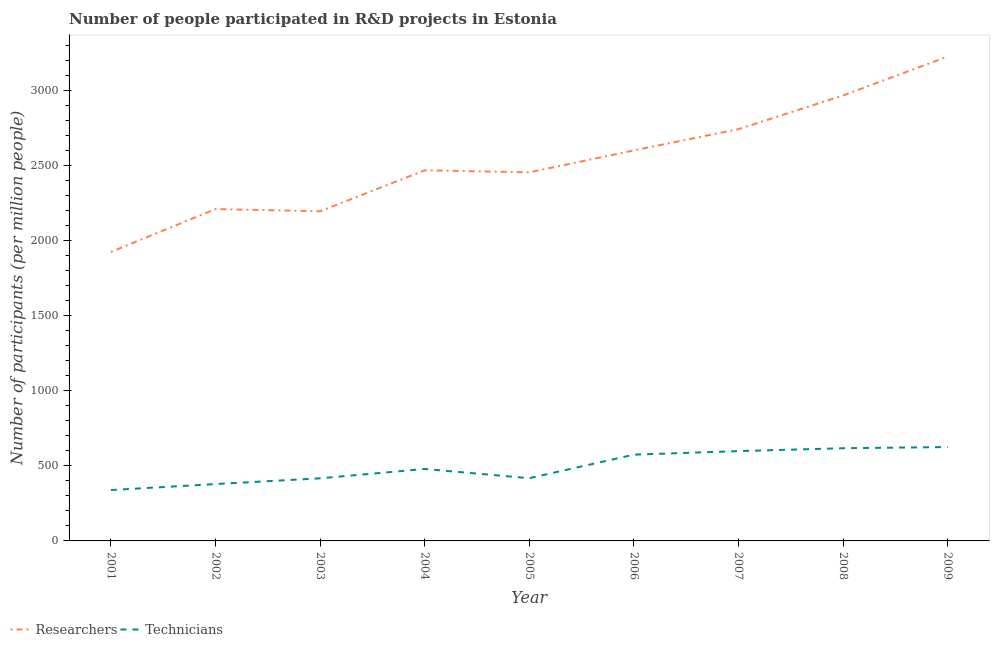Is the number of lines equal to the number of legend labels?
Offer a very short reply. Yes. What is the number of researchers in 2008?
Provide a short and direct response. 2969.53. Across all years, what is the maximum number of technicians?
Your answer should be compact. 625.74. Across all years, what is the minimum number of researchers?
Make the answer very short. 1926.35. In which year was the number of technicians maximum?
Keep it short and to the point. 2009. In which year was the number of technicians minimum?
Your response must be concise. 2001. What is the total number of technicians in the graph?
Give a very brief answer. 4450.96. What is the difference between the number of researchers in 2001 and that in 2009?
Ensure brevity in your answer.  -1302.66. What is the difference between the number of researchers in 2007 and the number of technicians in 2009?
Make the answer very short. 2119.32. What is the average number of researchers per year?
Offer a very short reply. 2534.57. In the year 2008, what is the difference between the number of researchers and number of technicians?
Offer a terse response. 2351.6. In how many years, is the number of researchers greater than 500?
Provide a short and direct response. 9. What is the ratio of the number of researchers in 2002 to that in 2008?
Provide a short and direct response. 0.74. Is the number of technicians in 2004 less than that in 2009?
Ensure brevity in your answer.  Yes. What is the difference between the highest and the second highest number of technicians?
Your answer should be compact. 7.8. What is the difference between the highest and the lowest number of technicians?
Offer a very short reply. 286.6. In how many years, is the number of researchers greater than the average number of researchers taken over all years?
Provide a succinct answer. 4. Is the sum of the number of researchers in 2002 and 2008 greater than the maximum number of technicians across all years?
Ensure brevity in your answer.  Yes. Does the number of technicians monotonically increase over the years?
Give a very brief answer. No. Is the number of researchers strictly greater than the number of technicians over the years?
Your response must be concise. Yes. Is the number of technicians strictly less than the number of researchers over the years?
Provide a short and direct response. Yes. Are the values on the major ticks of Y-axis written in scientific E-notation?
Ensure brevity in your answer.  No. Does the graph contain grids?
Provide a short and direct response. No. How many legend labels are there?
Offer a terse response. 2. What is the title of the graph?
Make the answer very short. Number of people participated in R&D projects in Estonia. Does "Depositors" appear as one of the legend labels in the graph?
Your answer should be very brief. No. What is the label or title of the X-axis?
Your response must be concise. Year. What is the label or title of the Y-axis?
Provide a short and direct response. Number of participants (per million people). What is the Number of participants (per million people) of Researchers in 2001?
Your answer should be compact. 1926.35. What is the Number of participants (per million people) of Technicians in 2001?
Your answer should be very brief. 339.14. What is the Number of participants (per million people) of Researchers in 2002?
Your answer should be very brief. 2212.28. What is the Number of participants (per million people) in Technicians in 2002?
Make the answer very short. 378.96. What is the Number of participants (per million people) of Researchers in 2003?
Keep it short and to the point. 2197.55. What is the Number of participants (per million people) in Technicians in 2003?
Give a very brief answer. 417.37. What is the Number of participants (per million people) of Researchers in 2004?
Offer a terse response. 2470.76. What is the Number of participants (per million people) of Technicians in 2004?
Provide a short and direct response. 479.63. What is the Number of participants (per million people) of Researchers in 2005?
Your response must be concise. 2457.1. What is the Number of participants (per million people) of Technicians in 2005?
Ensure brevity in your answer.  418.25. What is the Number of participants (per million people) in Researchers in 2006?
Offer a very short reply. 2603.44. What is the Number of participants (per million people) in Technicians in 2006?
Ensure brevity in your answer.  575.08. What is the Number of participants (per million people) of Researchers in 2007?
Make the answer very short. 2745.06. What is the Number of participants (per million people) in Technicians in 2007?
Provide a short and direct response. 598.85. What is the Number of participants (per million people) of Researchers in 2008?
Offer a terse response. 2969.53. What is the Number of participants (per million people) in Technicians in 2008?
Offer a terse response. 617.94. What is the Number of participants (per million people) of Researchers in 2009?
Offer a terse response. 3229.01. What is the Number of participants (per million people) in Technicians in 2009?
Provide a short and direct response. 625.74. Across all years, what is the maximum Number of participants (per million people) in Researchers?
Keep it short and to the point. 3229.01. Across all years, what is the maximum Number of participants (per million people) in Technicians?
Your answer should be compact. 625.74. Across all years, what is the minimum Number of participants (per million people) in Researchers?
Make the answer very short. 1926.35. Across all years, what is the minimum Number of participants (per million people) of Technicians?
Ensure brevity in your answer.  339.14. What is the total Number of participants (per million people) in Researchers in the graph?
Offer a terse response. 2.28e+04. What is the total Number of participants (per million people) of Technicians in the graph?
Provide a short and direct response. 4450.96. What is the difference between the Number of participants (per million people) of Researchers in 2001 and that in 2002?
Offer a terse response. -285.94. What is the difference between the Number of participants (per million people) of Technicians in 2001 and that in 2002?
Give a very brief answer. -39.82. What is the difference between the Number of participants (per million people) in Researchers in 2001 and that in 2003?
Offer a terse response. -271.21. What is the difference between the Number of participants (per million people) in Technicians in 2001 and that in 2003?
Your answer should be compact. -78.23. What is the difference between the Number of participants (per million people) of Researchers in 2001 and that in 2004?
Your answer should be very brief. -544.41. What is the difference between the Number of participants (per million people) of Technicians in 2001 and that in 2004?
Your response must be concise. -140.49. What is the difference between the Number of participants (per million people) in Researchers in 2001 and that in 2005?
Provide a succinct answer. -530.76. What is the difference between the Number of participants (per million people) in Technicians in 2001 and that in 2005?
Keep it short and to the point. -79.11. What is the difference between the Number of participants (per million people) of Researchers in 2001 and that in 2006?
Offer a very short reply. -677.09. What is the difference between the Number of participants (per million people) in Technicians in 2001 and that in 2006?
Provide a short and direct response. -235.94. What is the difference between the Number of participants (per million people) in Researchers in 2001 and that in 2007?
Ensure brevity in your answer.  -818.71. What is the difference between the Number of participants (per million people) of Technicians in 2001 and that in 2007?
Your response must be concise. -259.71. What is the difference between the Number of participants (per million people) in Researchers in 2001 and that in 2008?
Make the answer very short. -1043.19. What is the difference between the Number of participants (per million people) of Technicians in 2001 and that in 2008?
Keep it short and to the point. -278.8. What is the difference between the Number of participants (per million people) of Researchers in 2001 and that in 2009?
Ensure brevity in your answer.  -1302.66. What is the difference between the Number of participants (per million people) in Technicians in 2001 and that in 2009?
Offer a very short reply. -286.6. What is the difference between the Number of participants (per million people) of Researchers in 2002 and that in 2003?
Make the answer very short. 14.73. What is the difference between the Number of participants (per million people) in Technicians in 2002 and that in 2003?
Offer a very short reply. -38.41. What is the difference between the Number of participants (per million people) in Researchers in 2002 and that in 2004?
Make the answer very short. -258.48. What is the difference between the Number of participants (per million people) in Technicians in 2002 and that in 2004?
Ensure brevity in your answer.  -100.67. What is the difference between the Number of participants (per million people) of Researchers in 2002 and that in 2005?
Ensure brevity in your answer.  -244.82. What is the difference between the Number of participants (per million people) of Technicians in 2002 and that in 2005?
Your answer should be compact. -39.29. What is the difference between the Number of participants (per million people) in Researchers in 2002 and that in 2006?
Your answer should be compact. -391.16. What is the difference between the Number of participants (per million people) of Technicians in 2002 and that in 2006?
Your response must be concise. -196.12. What is the difference between the Number of participants (per million people) of Researchers in 2002 and that in 2007?
Your answer should be very brief. -532.78. What is the difference between the Number of participants (per million people) in Technicians in 2002 and that in 2007?
Give a very brief answer. -219.9. What is the difference between the Number of participants (per million people) in Researchers in 2002 and that in 2008?
Your answer should be very brief. -757.25. What is the difference between the Number of participants (per million people) in Technicians in 2002 and that in 2008?
Offer a terse response. -238.98. What is the difference between the Number of participants (per million people) in Researchers in 2002 and that in 2009?
Your response must be concise. -1016.73. What is the difference between the Number of participants (per million people) of Technicians in 2002 and that in 2009?
Give a very brief answer. -246.78. What is the difference between the Number of participants (per million people) of Researchers in 2003 and that in 2004?
Offer a terse response. -273.2. What is the difference between the Number of participants (per million people) of Technicians in 2003 and that in 2004?
Make the answer very short. -62.26. What is the difference between the Number of participants (per million people) of Researchers in 2003 and that in 2005?
Your answer should be compact. -259.55. What is the difference between the Number of participants (per million people) of Technicians in 2003 and that in 2005?
Your answer should be compact. -0.88. What is the difference between the Number of participants (per million people) of Researchers in 2003 and that in 2006?
Your response must be concise. -405.88. What is the difference between the Number of participants (per million people) of Technicians in 2003 and that in 2006?
Keep it short and to the point. -157.72. What is the difference between the Number of participants (per million people) in Researchers in 2003 and that in 2007?
Provide a succinct answer. -547.51. What is the difference between the Number of participants (per million people) in Technicians in 2003 and that in 2007?
Your answer should be compact. -181.49. What is the difference between the Number of participants (per million people) in Researchers in 2003 and that in 2008?
Your answer should be very brief. -771.98. What is the difference between the Number of participants (per million people) in Technicians in 2003 and that in 2008?
Your response must be concise. -200.57. What is the difference between the Number of participants (per million people) in Researchers in 2003 and that in 2009?
Your answer should be very brief. -1031.46. What is the difference between the Number of participants (per million people) of Technicians in 2003 and that in 2009?
Keep it short and to the point. -208.37. What is the difference between the Number of participants (per million people) in Researchers in 2004 and that in 2005?
Offer a very short reply. 13.66. What is the difference between the Number of participants (per million people) in Technicians in 2004 and that in 2005?
Your answer should be very brief. 61.38. What is the difference between the Number of participants (per million people) of Researchers in 2004 and that in 2006?
Give a very brief answer. -132.68. What is the difference between the Number of participants (per million people) of Technicians in 2004 and that in 2006?
Your answer should be compact. -95.45. What is the difference between the Number of participants (per million people) in Researchers in 2004 and that in 2007?
Keep it short and to the point. -274.3. What is the difference between the Number of participants (per million people) of Technicians in 2004 and that in 2007?
Your answer should be compact. -119.22. What is the difference between the Number of participants (per million people) in Researchers in 2004 and that in 2008?
Ensure brevity in your answer.  -498.78. What is the difference between the Number of participants (per million people) in Technicians in 2004 and that in 2008?
Your answer should be compact. -138.31. What is the difference between the Number of participants (per million people) of Researchers in 2004 and that in 2009?
Your answer should be very brief. -758.25. What is the difference between the Number of participants (per million people) of Technicians in 2004 and that in 2009?
Make the answer very short. -146.11. What is the difference between the Number of participants (per million people) in Researchers in 2005 and that in 2006?
Your response must be concise. -146.34. What is the difference between the Number of participants (per million people) in Technicians in 2005 and that in 2006?
Your answer should be very brief. -156.84. What is the difference between the Number of participants (per million people) of Researchers in 2005 and that in 2007?
Give a very brief answer. -287.96. What is the difference between the Number of participants (per million people) of Technicians in 2005 and that in 2007?
Ensure brevity in your answer.  -180.61. What is the difference between the Number of participants (per million people) of Researchers in 2005 and that in 2008?
Your answer should be very brief. -512.43. What is the difference between the Number of participants (per million people) of Technicians in 2005 and that in 2008?
Provide a short and direct response. -199.69. What is the difference between the Number of participants (per million people) of Researchers in 2005 and that in 2009?
Offer a terse response. -771.91. What is the difference between the Number of participants (per million people) of Technicians in 2005 and that in 2009?
Your answer should be compact. -207.5. What is the difference between the Number of participants (per million people) in Researchers in 2006 and that in 2007?
Your answer should be very brief. -141.62. What is the difference between the Number of participants (per million people) in Technicians in 2006 and that in 2007?
Provide a succinct answer. -23.77. What is the difference between the Number of participants (per million people) in Researchers in 2006 and that in 2008?
Your answer should be compact. -366.09. What is the difference between the Number of participants (per million people) of Technicians in 2006 and that in 2008?
Provide a succinct answer. -42.85. What is the difference between the Number of participants (per million people) in Researchers in 2006 and that in 2009?
Provide a succinct answer. -625.57. What is the difference between the Number of participants (per million people) of Technicians in 2006 and that in 2009?
Offer a very short reply. -50.66. What is the difference between the Number of participants (per million people) of Researchers in 2007 and that in 2008?
Provide a short and direct response. -224.47. What is the difference between the Number of participants (per million people) of Technicians in 2007 and that in 2008?
Your answer should be compact. -19.08. What is the difference between the Number of participants (per million people) in Researchers in 2007 and that in 2009?
Ensure brevity in your answer.  -483.95. What is the difference between the Number of participants (per million people) in Technicians in 2007 and that in 2009?
Keep it short and to the point. -26.89. What is the difference between the Number of participants (per million people) in Researchers in 2008 and that in 2009?
Provide a succinct answer. -259.48. What is the difference between the Number of participants (per million people) of Technicians in 2008 and that in 2009?
Offer a very short reply. -7.8. What is the difference between the Number of participants (per million people) of Researchers in 2001 and the Number of participants (per million people) of Technicians in 2002?
Offer a terse response. 1547.39. What is the difference between the Number of participants (per million people) in Researchers in 2001 and the Number of participants (per million people) in Technicians in 2003?
Give a very brief answer. 1508.98. What is the difference between the Number of participants (per million people) in Researchers in 2001 and the Number of participants (per million people) in Technicians in 2004?
Your response must be concise. 1446.72. What is the difference between the Number of participants (per million people) in Researchers in 2001 and the Number of participants (per million people) in Technicians in 2005?
Provide a short and direct response. 1508.1. What is the difference between the Number of participants (per million people) in Researchers in 2001 and the Number of participants (per million people) in Technicians in 2006?
Make the answer very short. 1351.26. What is the difference between the Number of participants (per million people) in Researchers in 2001 and the Number of participants (per million people) in Technicians in 2007?
Your answer should be compact. 1327.49. What is the difference between the Number of participants (per million people) of Researchers in 2001 and the Number of participants (per million people) of Technicians in 2008?
Offer a very short reply. 1308.41. What is the difference between the Number of participants (per million people) of Researchers in 2001 and the Number of participants (per million people) of Technicians in 2009?
Make the answer very short. 1300.6. What is the difference between the Number of participants (per million people) of Researchers in 2002 and the Number of participants (per million people) of Technicians in 2003?
Your answer should be very brief. 1794.91. What is the difference between the Number of participants (per million people) in Researchers in 2002 and the Number of participants (per million people) in Technicians in 2004?
Offer a very short reply. 1732.65. What is the difference between the Number of participants (per million people) of Researchers in 2002 and the Number of participants (per million people) of Technicians in 2005?
Offer a very short reply. 1794.04. What is the difference between the Number of participants (per million people) in Researchers in 2002 and the Number of participants (per million people) in Technicians in 2006?
Provide a succinct answer. 1637.2. What is the difference between the Number of participants (per million people) in Researchers in 2002 and the Number of participants (per million people) in Technicians in 2007?
Your response must be concise. 1613.43. What is the difference between the Number of participants (per million people) of Researchers in 2002 and the Number of participants (per million people) of Technicians in 2008?
Ensure brevity in your answer.  1594.34. What is the difference between the Number of participants (per million people) of Researchers in 2002 and the Number of participants (per million people) of Technicians in 2009?
Give a very brief answer. 1586.54. What is the difference between the Number of participants (per million people) of Researchers in 2003 and the Number of participants (per million people) of Technicians in 2004?
Offer a terse response. 1717.92. What is the difference between the Number of participants (per million people) of Researchers in 2003 and the Number of participants (per million people) of Technicians in 2005?
Provide a succinct answer. 1779.31. What is the difference between the Number of participants (per million people) in Researchers in 2003 and the Number of participants (per million people) in Technicians in 2006?
Your answer should be very brief. 1622.47. What is the difference between the Number of participants (per million people) of Researchers in 2003 and the Number of participants (per million people) of Technicians in 2007?
Your response must be concise. 1598.7. What is the difference between the Number of participants (per million people) in Researchers in 2003 and the Number of participants (per million people) in Technicians in 2008?
Make the answer very short. 1579.62. What is the difference between the Number of participants (per million people) of Researchers in 2003 and the Number of participants (per million people) of Technicians in 2009?
Your answer should be compact. 1571.81. What is the difference between the Number of participants (per million people) in Researchers in 2004 and the Number of participants (per million people) in Technicians in 2005?
Your answer should be compact. 2052.51. What is the difference between the Number of participants (per million people) in Researchers in 2004 and the Number of participants (per million people) in Technicians in 2006?
Your response must be concise. 1895.67. What is the difference between the Number of participants (per million people) in Researchers in 2004 and the Number of participants (per million people) in Technicians in 2007?
Your answer should be compact. 1871.9. What is the difference between the Number of participants (per million people) of Researchers in 2004 and the Number of participants (per million people) of Technicians in 2008?
Provide a short and direct response. 1852.82. What is the difference between the Number of participants (per million people) of Researchers in 2004 and the Number of participants (per million people) of Technicians in 2009?
Provide a short and direct response. 1845.02. What is the difference between the Number of participants (per million people) in Researchers in 2005 and the Number of participants (per million people) in Technicians in 2006?
Your answer should be very brief. 1882.02. What is the difference between the Number of participants (per million people) in Researchers in 2005 and the Number of participants (per million people) in Technicians in 2007?
Your answer should be very brief. 1858.25. What is the difference between the Number of participants (per million people) in Researchers in 2005 and the Number of participants (per million people) in Technicians in 2008?
Your answer should be very brief. 1839.16. What is the difference between the Number of participants (per million people) of Researchers in 2005 and the Number of participants (per million people) of Technicians in 2009?
Provide a short and direct response. 1831.36. What is the difference between the Number of participants (per million people) in Researchers in 2006 and the Number of participants (per million people) in Technicians in 2007?
Your answer should be compact. 2004.58. What is the difference between the Number of participants (per million people) in Researchers in 2006 and the Number of participants (per million people) in Technicians in 2008?
Your answer should be very brief. 1985.5. What is the difference between the Number of participants (per million people) of Researchers in 2006 and the Number of participants (per million people) of Technicians in 2009?
Make the answer very short. 1977.7. What is the difference between the Number of participants (per million people) of Researchers in 2007 and the Number of participants (per million people) of Technicians in 2008?
Ensure brevity in your answer.  2127.12. What is the difference between the Number of participants (per million people) in Researchers in 2007 and the Number of participants (per million people) in Technicians in 2009?
Your response must be concise. 2119.32. What is the difference between the Number of participants (per million people) of Researchers in 2008 and the Number of participants (per million people) of Technicians in 2009?
Keep it short and to the point. 2343.79. What is the average Number of participants (per million people) in Researchers per year?
Provide a short and direct response. 2534.57. What is the average Number of participants (per million people) of Technicians per year?
Ensure brevity in your answer.  494.55. In the year 2001, what is the difference between the Number of participants (per million people) in Researchers and Number of participants (per million people) in Technicians?
Your answer should be very brief. 1587.21. In the year 2002, what is the difference between the Number of participants (per million people) in Researchers and Number of participants (per million people) in Technicians?
Your response must be concise. 1833.32. In the year 2003, what is the difference between the Number of participants (per million people) of Researchers and Number of participants (per million people) of Technicians?
Keep it short and to the point. 1780.19. In the year 2004, what is the difference between the Number of participants (per million people) in Researchers and Number of participants (per million people) in Technicians?
Provide a short and direct response. 1991.13. In the year 2005, what is the difference between the Number of participants (per million people) in Researchers and Number of participants (per million people) in Technicians?
Offer a very short reply. 2038.86. In the year 2006, what is the difference between the Number of participants (per million people) in Researchers and Number of participants (per million people) in Technicians?
Make the answer very short. 2028.36. In the year 2007, what is the difference between the Number of participants (per million people) of Researchers and Number of participants (per million people) of Technicians?
Your response must be concise. 2146.21. In the year 2008, what is the difference between the Number of participants (per million people) in Researchers and Number of participants (per million people) in Technicians?
Offer a terse response. 2351.6. In the year 2009, what is the difference between the Number of participants (per million people) of Researchers and Number of participants (per million people) of Technicians?
Offer a terse response. 2603.27. What is the ratio of the Number of participants (per million people) of Researchers in 2001 to that in 2002?
Your answer should be compact. 0.87. What is the ratio of the Number of participants (per million people) of Technicians in 2001 to that in 2002?
Give a very brief answer. 0.89. What is the ratio of the Number of participants (per million people) of Researchers in 2001 to that in 2003?
Offer a terse response. 0.88. What is the ratio of the Number of participants (per million people) of Technicians in 2001 to that in 2003?
Your response must be concise. 0.81. What is the ratio of the Number of participants (per million people) in Researchers in 2001 to that in 2004?
Provide a short and direct response. 0.78. What is the ratio of the Number of participants (per million people) in Technicians in 2001 to that in 2004?
Keep it short and to the point. 0.71. What is the ratio of the Number of participants (per million people) of Researchers in 2001 to that in 2005?
Offer a very short reply. 0.78. What is the ratio of the Number of participants (per million people) of Technicians in 2001 to that in 2005?
Your answer should be compact. 0.81. What is the ratio of the Number of participants (per million people) of Researchers in 2001 to that in 2006?
Keep it short and to the point. 0.74. What is the ratio of the Number of participants (per million people) of Technicians in 2001 to that in 2006?
Provide a short and direct response. 0.59. What is the ratio of the Number of participants (per million people) in Researchers in 2001 to that in 2007?
Keep it short and to the point. 0.7. What is the ratio of the Number of participants (per million people) of Technicians in 2001 to that in 2007?
Offer a terse response. 0.57. What is the ratio of the Number of participants (per million people) of Researchers in 2001 to that in 2008?
Offer a very short reply. 0.65. What is the ratio of the Number of participants (per million people) of Technicians in 2001 to that in 2008?
Your answer should be very brief. 0.55. What is the ratio of the Number of participants (per million people) of Researchers in 2001 to that in 2009?
Offer a terse response. 0.6. What is the ratio of the Number of participants (per million people) in Technicians in 2001 to that in 2009?
Give a very brief answer. 0.54. What is the ratio of the Number of participants (per million people) in Researchers in 2002 to that in 2003?
Offer a very short reply. 1.01. What is the ratio of the Number of participants (per million people) of Technicians in 2002 to that in 2003?
Give a very brief answer. 0.91. What is the ratio of the Number of participants (per million people) in Researchers in 2002 to that in 2004?
Your response must be concise. 0.9. What is the ratio of the Number of participants (per million people) in Technicians in 2002 to that in 2004?
Ensure brevity in your answer.  0.79. What is the ratio of the Number of participants (per million people) of Researchers in 2002 to that in 2005?
Ensure brevity in your answer.  0.9. What is the ratio of the Number of participants (per million people) in Technicians in 2002 to that in 2005?
Keep it short and to the point. 0.91. What is the ratio of the Number of participants (per million people) in Researchers in 2002 to that in 2006?
Your answer should be compact. 0.85. What is the ratio of the Number of participants (per million people) of Technicians in 2002 to that in 2006?
Ensure brevity in your answer.  0.66. What is the ratio of the Number of participants (per million people) of Researchers in 2002 to that in 2007?
Provide a short and direct response. 0.81. What is the ratio of the Number of participants (per million people) in Technicians in 2002 to that in 2007?
Offer a terse response. 0.63. What is the ratio of the Number of participants (per million people) of Researchers in 2002 to that in 2008?
Give a very brief answer. 0.74. What is the ratio of the Number of participants (per million people) of Technicians in 2002 to that in 2008?
Make the answer very short. 0.61. What is the ratio of the Number of participants (per million people) of Researchers in 2002 to that in 2009?
Your answer should be very brief. 0.69. What is the ratio of the Number of participants (per million people) of Technicians in 2002 to that in 2009?
Your response must be concise. 0.61. What is the ratio of the Number of participants (per million people) of Researchers in 2003 to that in 2004?
Provide a succinct answer. 0.89. What is the ratio of the Number of participants (per million people) in Technicians in 2003 to that in 2004?
Give a very brief answer. 0.87. What is the ratio of the Number of participants (per million people) in Researchers in 2003 to that in 2005?
Offer a very short reply. 0.89. What is the ratio of the Number of participants (per million people) of Technicians in 2003 to that in 2005?
Give a very brief answer. 1. What is the ratio of the Number of participants (per million people) in Researchers in 2003 to that in 2006?
Make the answer very short. 0.84. What is the ratio of the Number of participants (per million people) in Technicians in 2003 to that in 2006?
Provide a short and direct response. 0.73. What is the ratio of the Number of participants (per million people) in Researchers in 2003 to that in 2007?
Make the answer very short. 0.8. What is the ratio of the Number of participants (per million people) of Technicians in 2003 to that in 2007?
Your answer should be very brief. 0.7. What is the ratio of the Number of participants (per million people) in Researchers in 2003 to that in 2008?
Provide a succinct answer. 0.74. What is the ratio of the Number of participants (per million people) of Technicians in 2003 to that in 2008?
Offer a very short reply. 0.68. What is the ratio of the Number of participants (per million people) in Researchers in 2003 to that in 2009?
Give a very brief answer. 0.68. What is the ratio of the Number of participants (per million people) in Technicians in 2003 to that in 2009?
Keep it short and to the point. 0.67. What is the ratio of the Number of participants (per million people) in Researchers in 2004 to that in 2005?
Offer a very short reply. 1.01. What is the ratio of the Number of participants (per million people) in Technicians in 2004 to that in 2005?
Offer a very short reply. 1.15. What is the ratio of the Number of participants (per million people) of Researchers in 2004 to that in 2006?
Provide a short and direct response. 0.95. What is the ratio of the Number of participants (per million people) in Technicians in 2004 to that in 2006?
Your answer should be very brief. 0.83. What is the ratio of the Number of participants (per million people) of Researchers in 2004 to that in 2007?
Provide a short and direct response. 0.9. What is the ratio of the Number of participants (per million people) in Technicians in 2004 to that in 2007?
Provide a short and direct response. 0.8. What is the ratio of the Number of participants (per million people) in Researchers in 2004 to that in 2008?
Keep it short and to the point. 0.83. What is the ratio of the Number of participants (per million people) in Technicians in 2004 to that in 2008?
Keep it short and to the point. 0.78. What is the ratio of the Number of participants (per million people) of Researchers in 2004 to that in 2009?
Make the answer very short. 0.77. What is the ratio of the Number of participants (per million people) in Technicians in 2004 to that in 2009?
Keep it short and to the point. 0.77. What is the ratio of the Number of participants (per million people) in Researchers in 2005 to that in 2006?
Your answer should be compact. 0.94. What is the ratio of the Number of participants (per million people) of Technicians in 2005 to that in 2006?
Provide a short and direct response. 0.73. What is the ratio of the Number of participants (per million people) in Researchers in 2005 to that in 2007?
Give a very brief answer. 0.9. What is the ratio of the Number of participants (per million people) of Technicians in 2005 to that in 2007?
Provide a succinct answer. 0.7. What is the ratio of the Number of participants (per million people) in Researchers in 2005 to that in 2008?
Your response must be concise. 0.83. What is the ratio of the Number of participants (per million people) in Technicians in 2005 to that in 2008?
Provide a succinct answer. 0.68. What is the ratio of the Number of participants (per million people) in Researchers in 2005 to that in 2009?
Provide a short and direct response. 0.76. What is the ratio of the Number of participants (per million people) in Technicians in 2005 to that in 2009?
Give a very brief answer. 0.67. What is the ratio of the Number of participants (per million people) of Researchers in 2006 to that in 2007?
Your response must be concise. 0.95. What is the ratio of the Number of participants (per million people) of Technicians in 2006 to that in 2007?
Keep it short and to the point. 0.96. What is the ratio of the Number of participants (per million people) in Researchers in 2006 to that in 2008?
Offer a terse response. 0.88. What is the ratio of the Number of participants (per million people) of Technicians in 2006 to that in 2008?
Your response must be concise. 0.93. What is the ratio of the Number of participants (per million people) of Researchers in 2006 to that in 2009?
Your answer should be very brief. 0.81. What is the ratio of the Number of participants (per million people) in Technicians in 2006 to that in 2009?
Keep it short and to the point. 0.92. What is the ratio of the Number of participants (per million people) of Researchers in 2007 to that in 2008?
Your response must be concise. 0.92. What is the ratio of the Number of participants (per million people) in Technicians in 2007 to that in 2008?
Your answer should be compact. 0.97. What is the ratio of the Number of participants (per million people) in Researchers in 2007 to that in 2009?
Provide a short and direct response. 0.85. What is the ratio of the Number of participants (per million people) of Researchers in 2008 to that in 2009?
Offer a terse response. 0.92. What is the ratio of the Number of participants (per million people) of Technicians in 2008 to that in 2009?
Your answer should be compact. 0.99. What is the difference between the highest and the second highest Number of participants (per million people) in Researchers?
Your answer should be very brief. 259.48. What is the difference between the highest and the second highest Number of participants (per million people) of Technicians?
Give a very brief answer. 7.8. What is the difference between the highest and the lowest Number of participants (per million people) in Researchers?
Your response must be concise. 1302.66. What is the difference between the highest and the lowest Number of participants (per million people) of Technicians?
Keep it short and to the point. 286.6. 